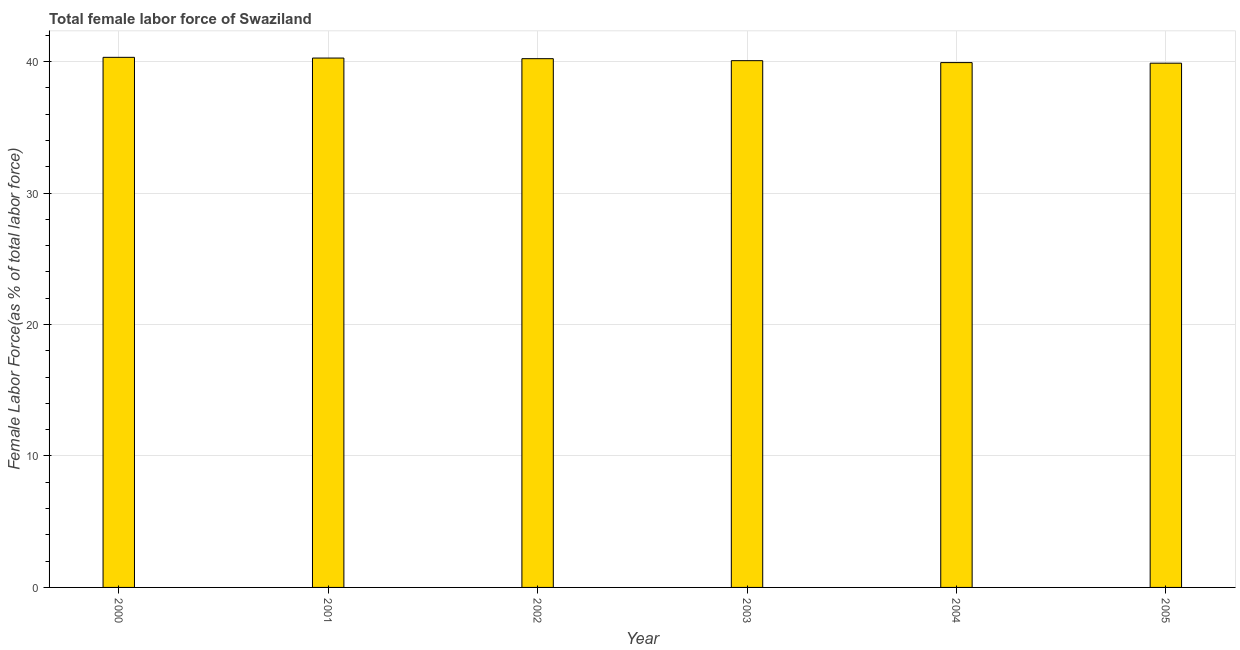What is the title of the graph?
Keep it short and to the point. Total female labor force of Swaziland. What is the label or title of the Y-axis?
Provide a succinct answer. Female Labor Force(as % of total labor force). What is the total female labor force in 2000?
Ensure brevity in your answer.  40.32. Across all years, what is the maximum total female labor force?
Provide a succinct answer. 40.32. Across all years, what is the minimum total female labor force?
Your answer should be very brief. 39.88. What is the sum of the total female labor force?
Provide a succinct answer. 240.67. What is the difference between the total female labor force in 2000 and 2001?
Keep it short and to the point. 0.06. What is the average total female labor force per year?
Provide a short and direct response. 40.11. What is the median total female labor force?
Make the answer very short. 40.14. In how many years, is the total female labor force greater than 28 %?
Your answer should be compact. 6. Do a majority of the years between 2000 and 2005 (inclusive) have total female labor force greater than 22 %?
Give a very brief answer. Yes. Is the total female labor force in 2003 less than that in 2005?
Ensure brevity in your answer.  No. What is the difference between the highest and the second highest total female labor force?
Provide a short and direct response. 0.06. What is the difference between the highest and the lowest total female labor force?
Provide a succinct answer. 0.45. In how many years, is the total female labor force greater than the average total female labor force taken over all years?
Offer a terse response. 3. Are all the bars in the graph horizontal?
Give a very brief answer. No. How many years are there in the graph?
Your answer should be compact. 6. What is the difference between two consecutive major ticks on the Y-axis?
Keep it short and to the point. 10. What is the Female Labor Force(as % of total labor force) in 2000?
Your answer should be compact. 40.32. What is the Female Labor Force(as % of total labor force) in 2001?
Your response must be concise. 40.27. What is the Female Labor Force(as % of total labor force) in 2002?
Your answer should be very brief. 40.22. What is the Female Labor Force(as % of total labor force) of 2003?
Make the answer very short. 40.07. What is the Female Labor Force(as % of total labor force) of 2004?
Offer a very short reply. 39.92. What is the Female Labor Force(as % of total labor force) of 2005?
Offer a very short reply. 39.88. What is the difference between the Female Labor Force(as % of total labor force) in 2000 and 2001?
Your answer should be compact. 0.06. What is the difference between the Female Labor Force(as % of total labor force) in 2000 and 2002?
Provide a short and direct response. 0.1. What is the difference between the Female Labor Force(as % of total labor force) in 2000 and 2003?
Ensure brevity in your answer.  0.25. What is the difference between the Female Labor Force(as % of total labor force) in 2000 and 2004?
Your response must be concise. 0.4. What is the difference between the Female Labor Force(as % of total labor force) in 2000 and 2005?
Your answer should be compact. 0.45. What is the difference between the Female Labor Force(as % of total labor force) in 2001 and 2002?
Provide a succinct answer. 0.05. What is the difference between the Female Labor Force(as % of total labor force) in 2001 and 2003?
Your answer should be very brief. 0.2. What is the difference between the Female Labor Force(as % of total labor force) in 2001 and 2004?
Your answer should be compact. 0.35. What is the difference between the Female Labor Force(as % of total labor force) in 2001 and 2005?
Give a very brief answer. 0.39. What is the difference between the Female Labor Force(as % of total labor force) in 2002 and 2003?
Your response must be concise. 0.15. What is the difference between the Female Labor Force(as % of total labor force) in 2002 and 2004?
Offer a very short reply. 0.3. What is the difference between the Female Labor Force(as % of total labor force) in 2002 and 2005?
Make the answer very short. 0.34. What is the difference between the Female Labor Force(as % of total labor force) in 2003 and 2004?
Provide a succinct answer. 0.15. What is the difference between the Female Labor Force(as % of total labor force) in 2003 and 2005?
Make the answer very short. 0.19. What is the difference between the Female Labor Force(as % of total labor force) in 2004 and 2005?
Make the answer very short. 0.04. What is the ratio of the Female Labor Force(as % of total labor force) in 2000 to that in 2002?
Provide a succinct answer. 1. What is the ratio of the Female Labor Force(as % of total labor force) in 2000 to that in 2003?
Your response must be concise. 1.01. What is the ratio of the Female Labor Force(as % of total labor force) in 2000 to that in 2004?
Your answer should be compact. 1.01. What is the ratio of the Female Labor Force(as % of total labor force) in 2001 to that in 2003?
Give a very brief answer. 1. What is the ratio of the Female Labor Force(as % of total labor force) in 2001 to that in 2005?
Make the answer very short. 1.01. What is the ratio of the Female Labor Force(as % of total labor force) in 2002 to that in 2003?
Your answer should be very brief. 1. What is the ratio of the Female Labor Force(as % of total labor force) in 2003 to that in 2005?
Provide a short and direct response. 1. 